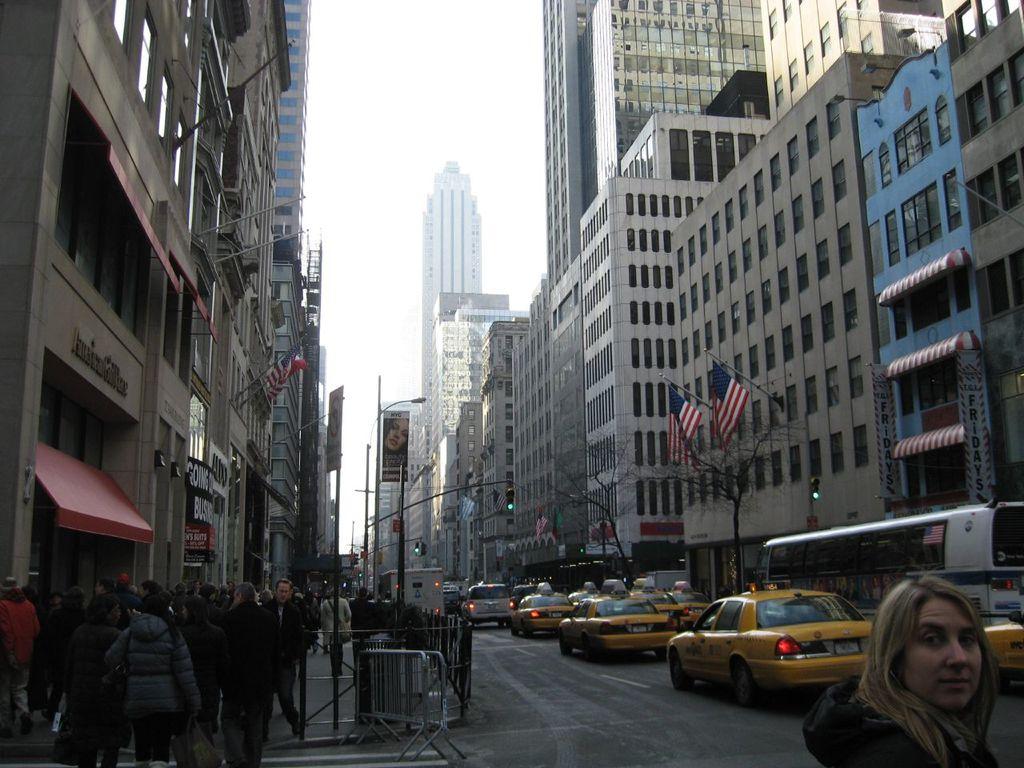What restaurant's name is written vertically twice on the banners to the right?
Give a very brief answer. Tgi fridays. 